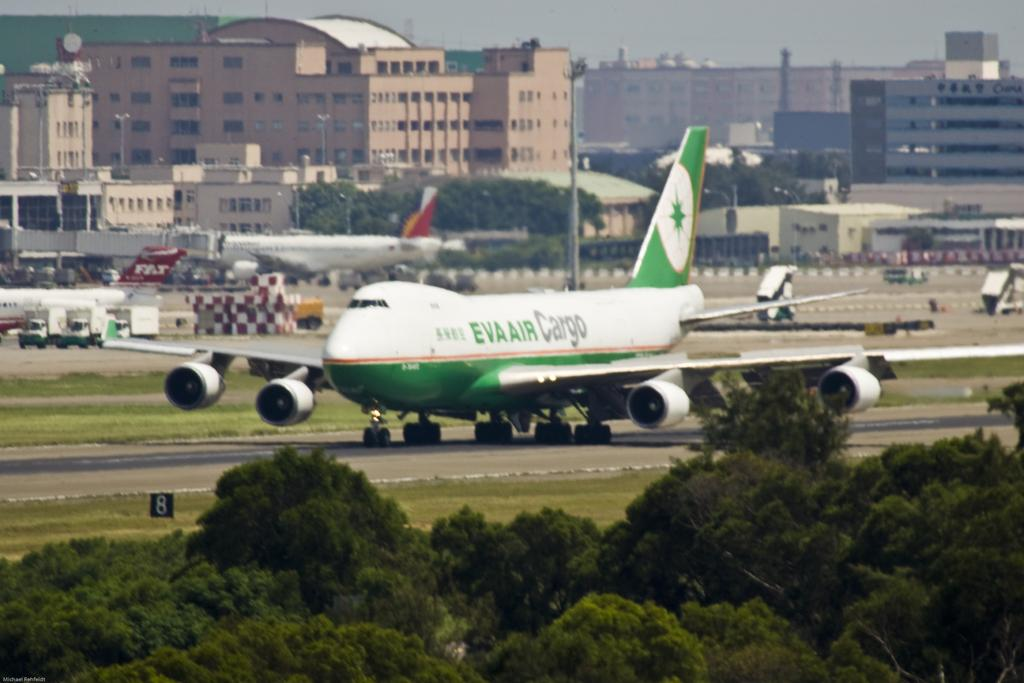What is the unusual object on the road in the image? There is an aeroplane on the road in the image. What type of vegetation can be seen in the image? There is grass visible in the image, and there are also trees. What structures are present in the image? There are poles, buildings, and boards visible in the image. What else can be seen in the image besides the structures and vegetation? There are vehicles in the image as well. What is visible in the background of the image? The sky is visible in the background of the image. What type of wilderness can be seen in the image? There is no wilderness present in the image; it features an aeroplane on the road, grass, trees, poles, buildings, boards, vehicles, and the sky. What record is being set by the aeroplane on the road in the image? There is no indication in the image that a record is being set; it simply shows an aeroplane on the road. 